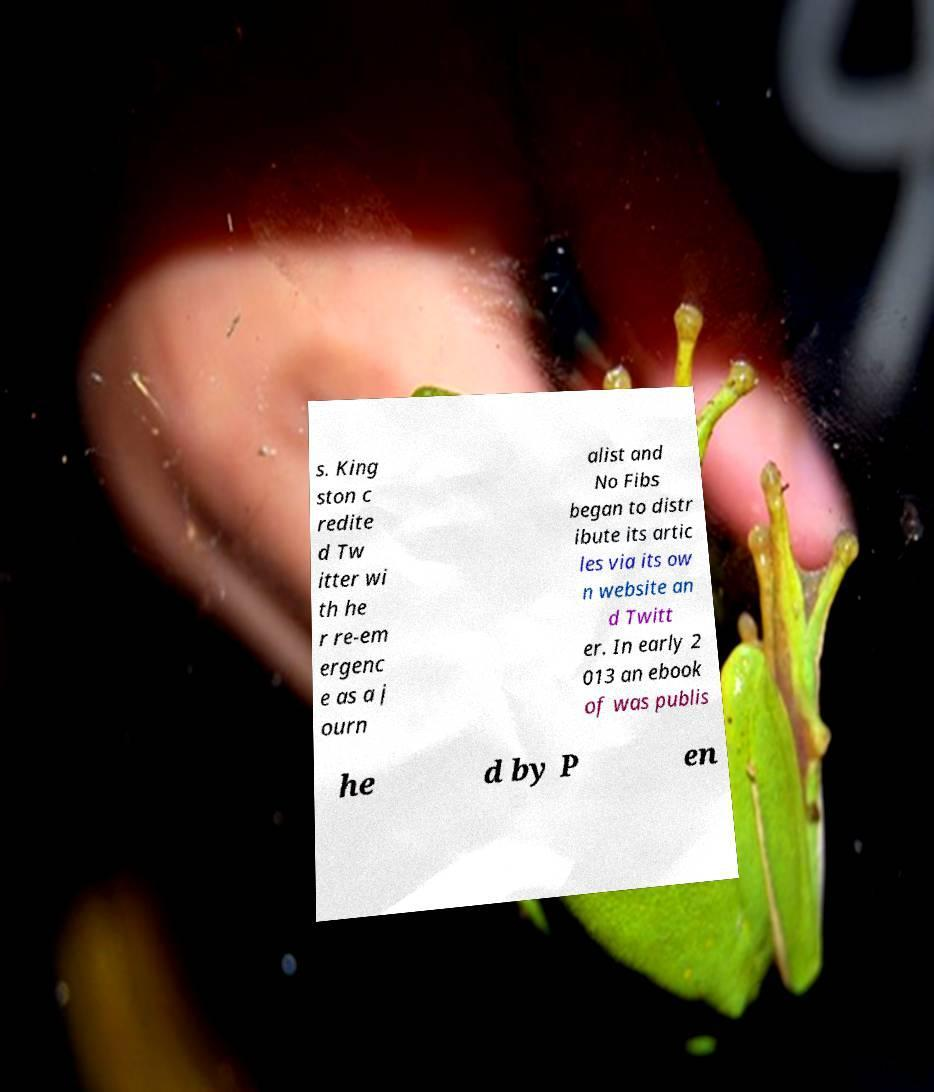Could you extract and type out the text from this image? s. King ston c redite d Tw itter wi th he r re-em ergenc e as a j ourn alist and No Fibs began to distr ibute its artic les via its ow n website an d Twitt er. In early 2 013 an ebook of was publis he d by P en 